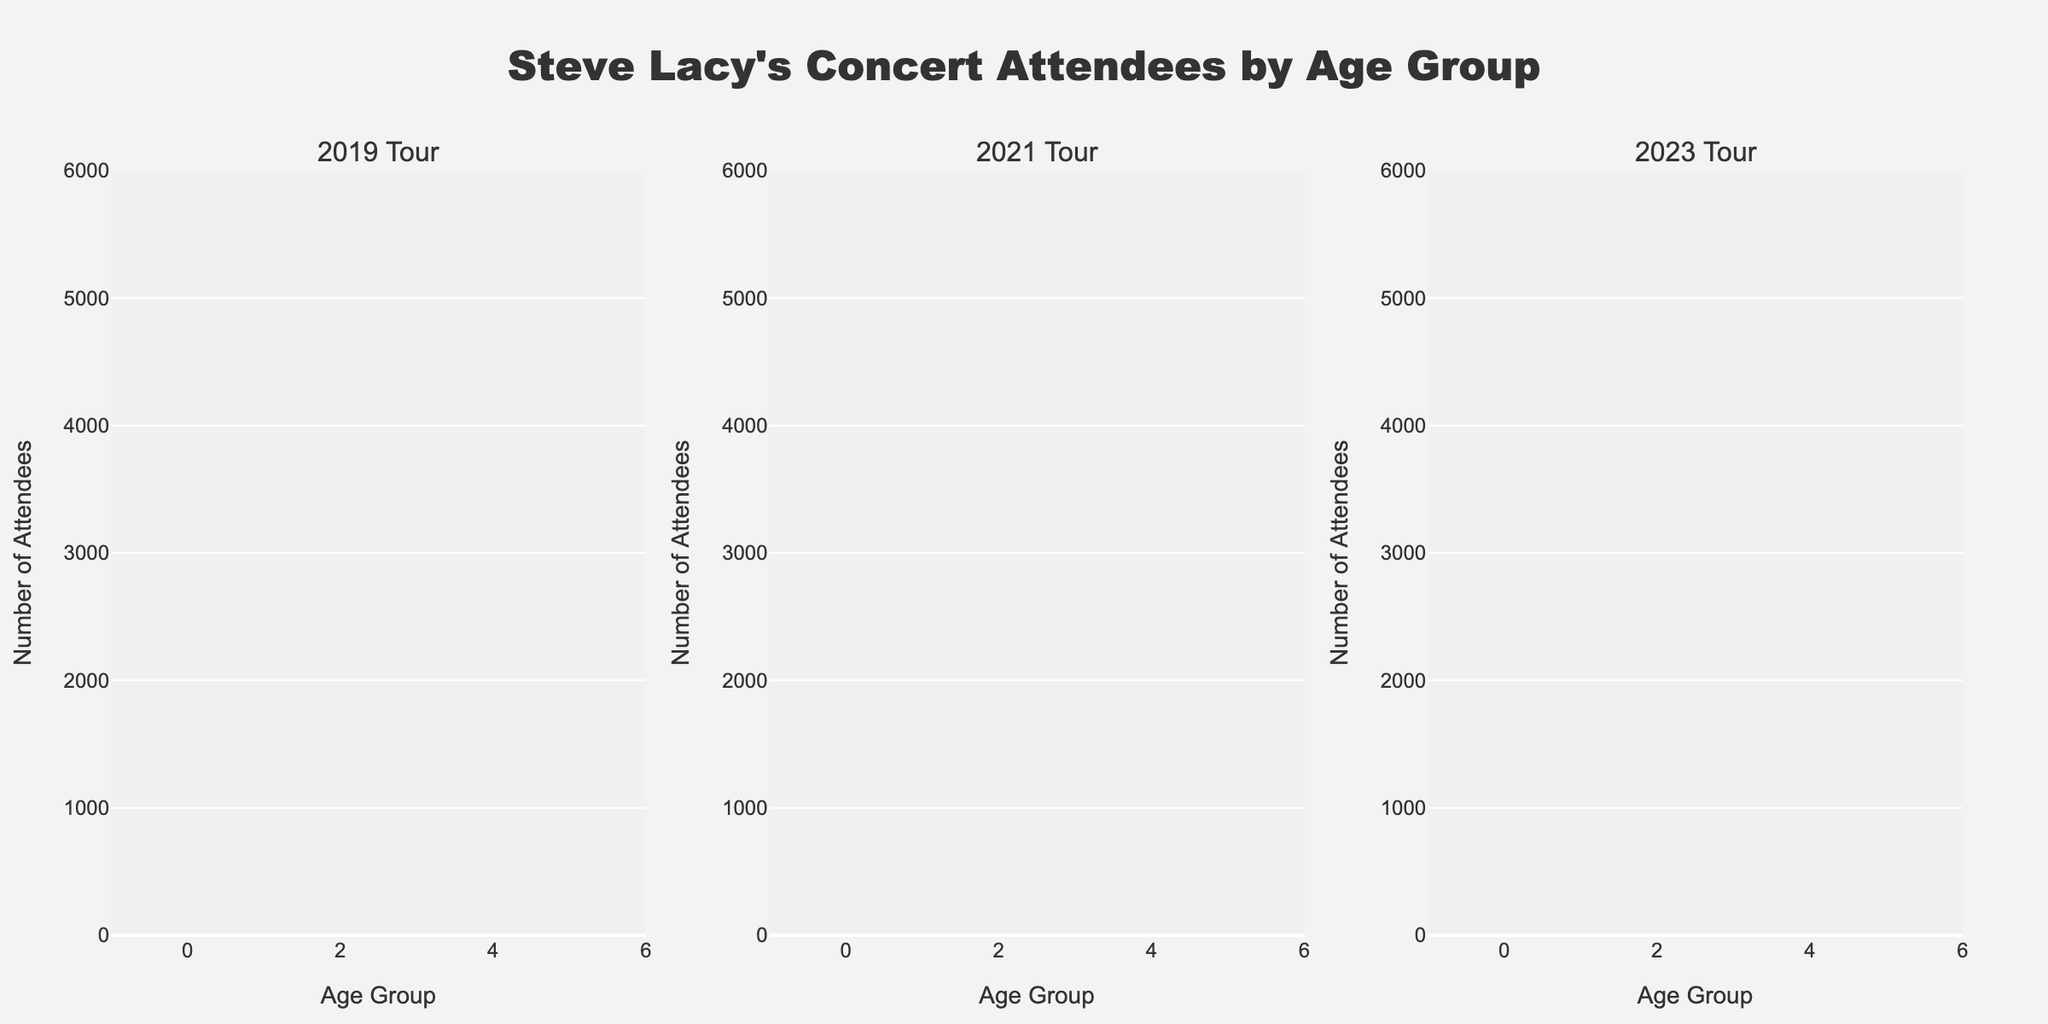What is the title of the figure? The title is displayed at the top center of the figure.
Answer: "Steve Lacy's Concert Attendees by Age Group" Which age group had the highest number of attendees in 2023? Look at the bar heights for each age group in the 2023 Tour subplot. The highest bar corresponds to the 18-24 age group.
Answer: 18-24 How many attendees were under 18 in 2019 and 2021 combined? Add the number of attendees under 18 for 2019 and 2021 from the bars in the respective subplots. 1200 (2019) + 1800 (2021) = 3000
Answer: 3000 Which tour year had the smallest number of attendees in the 45+ age group? Compare the heights of the bars for the 45+ age group across the three subplots. The shortest bar is in the 2019 Tour subplot.
Answer: 2019 What is the difference in the number of attendees in the 25-34 age group between the 2019 and 2021 tours? Subtract the number of attendees in the 25-34 age group in 2019 from that in 2021. 3500 (2021) - 2800 (2019) = 700
Answer: 700 How many age groups are displayed for each tour year? Count the number of bars (age groups) in one subplot, the count is consistent for all subplots.
Answer: 5 Which year saw the largest increase in the number of attendees under 18 compared to the previous tour year? Compare the changes in the number of attendees under 18 between 2019-2021 and 2021-2023. The increase from 2021 to 2023 is larger: 1800 (2021) to 2500 (2023), an increase of 700, compared to 1200 (2019) to 1800 (2021), an increase of only 600.
Answer: 2023 What was the total number of attendees in the 35-44 age group across all three tour years? Sum the number of attendees in the 35-44 age group across all three subplots. 1500 (2019) + 2000 (2021) + 2800 (2023) = 6300
Answer: 6300 Did the number of attendees in the 18-24 age group increase or decrease from 2019 to 2023? Compare the 18-24 age group's bar heights from 2019 and 2023. The number increased from 3500 (2019) to 5000 (2023).
Answer: Increase Which age group consistently had more than 2000 attendees in all examined tour years? Check the bars to see which age group consistently exceeds 2000 attendees in all three subplots. The 18-24 and 25-34 age groups meet this criterion.
Answer: 18-24 and 25-34 